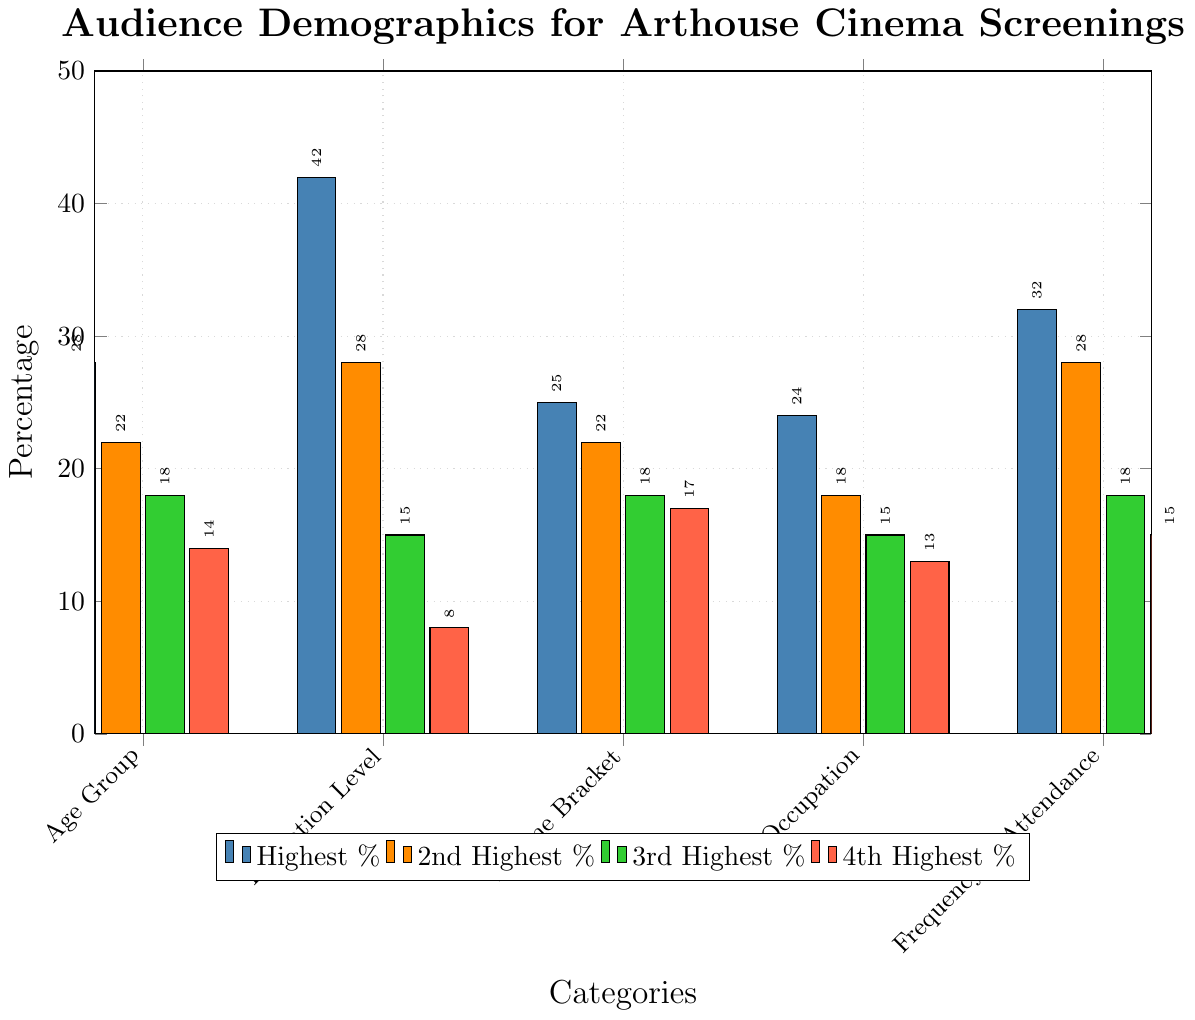Which category has the highest percentage in the Age Group? Looking at the bars for the Age Group category, we see that the highest bar represents 25-34 with a percentage of 28%.
Answer: 25-34 Which occupation group has the least percentage participation? We compare the heights of the bars within the Occupation category and find that the Healthcare group with 9% is the shortest bar.
Answer: Healthcare What is the total percentage of participants with a Bachelor's Degree and a Master's Degree? Summing the percentages for Bachelor's Degree (42%) and Master's Degree (28%) in the Education Level category, we get 42 + 28 = 70.
Answer: 70 Which income bracket has more participants, $50k-$75k or $75k-$100k? By comparing the bars, we see that the $50k-$75k bracket has a higher percentage (25%) than the $75k-$100k bracket (22%).
Answer: $50k-$75k What age group has half the percentage of the 18-24 group? The 18-24 age group has 12%. Half of 12% is 6%, which corresponds to the 65+ age group.
Answer: 65+ Compare the sum of the percentages for the Weekly and Bi-weekly attendance frequencies. Adding the percentages for Weekly (7%) and Bi-weekly (15%) gives us 7 + 15 = 22.
Answer: 22 Which group has a higher percentage: Educators in Occupation or $30k-$50k Income Bracket? Referring to the Occupation and Income Bracket categories, Educators have 18% while the $30k-$50k income bracket has 18%. Both have the same percentage.
Answer: Both are equal What is the difference in percentage between Creative Professionals and Students in the Occupation category? The bar for Creative Professionals is at 24% and for Students is at 11%. The difference is 24 - 11 = 13.
Answer: 13 Is the highest percentage in the Frequency of Attendance category greater than the highest percentage in the Income Bracket category? The highest percentage for Frequency of Attendance is Monthly with 32%, and for Income Bracket, it's $50k-$75k with 25%. 32% is greater than 25%.
Answer: Yes 